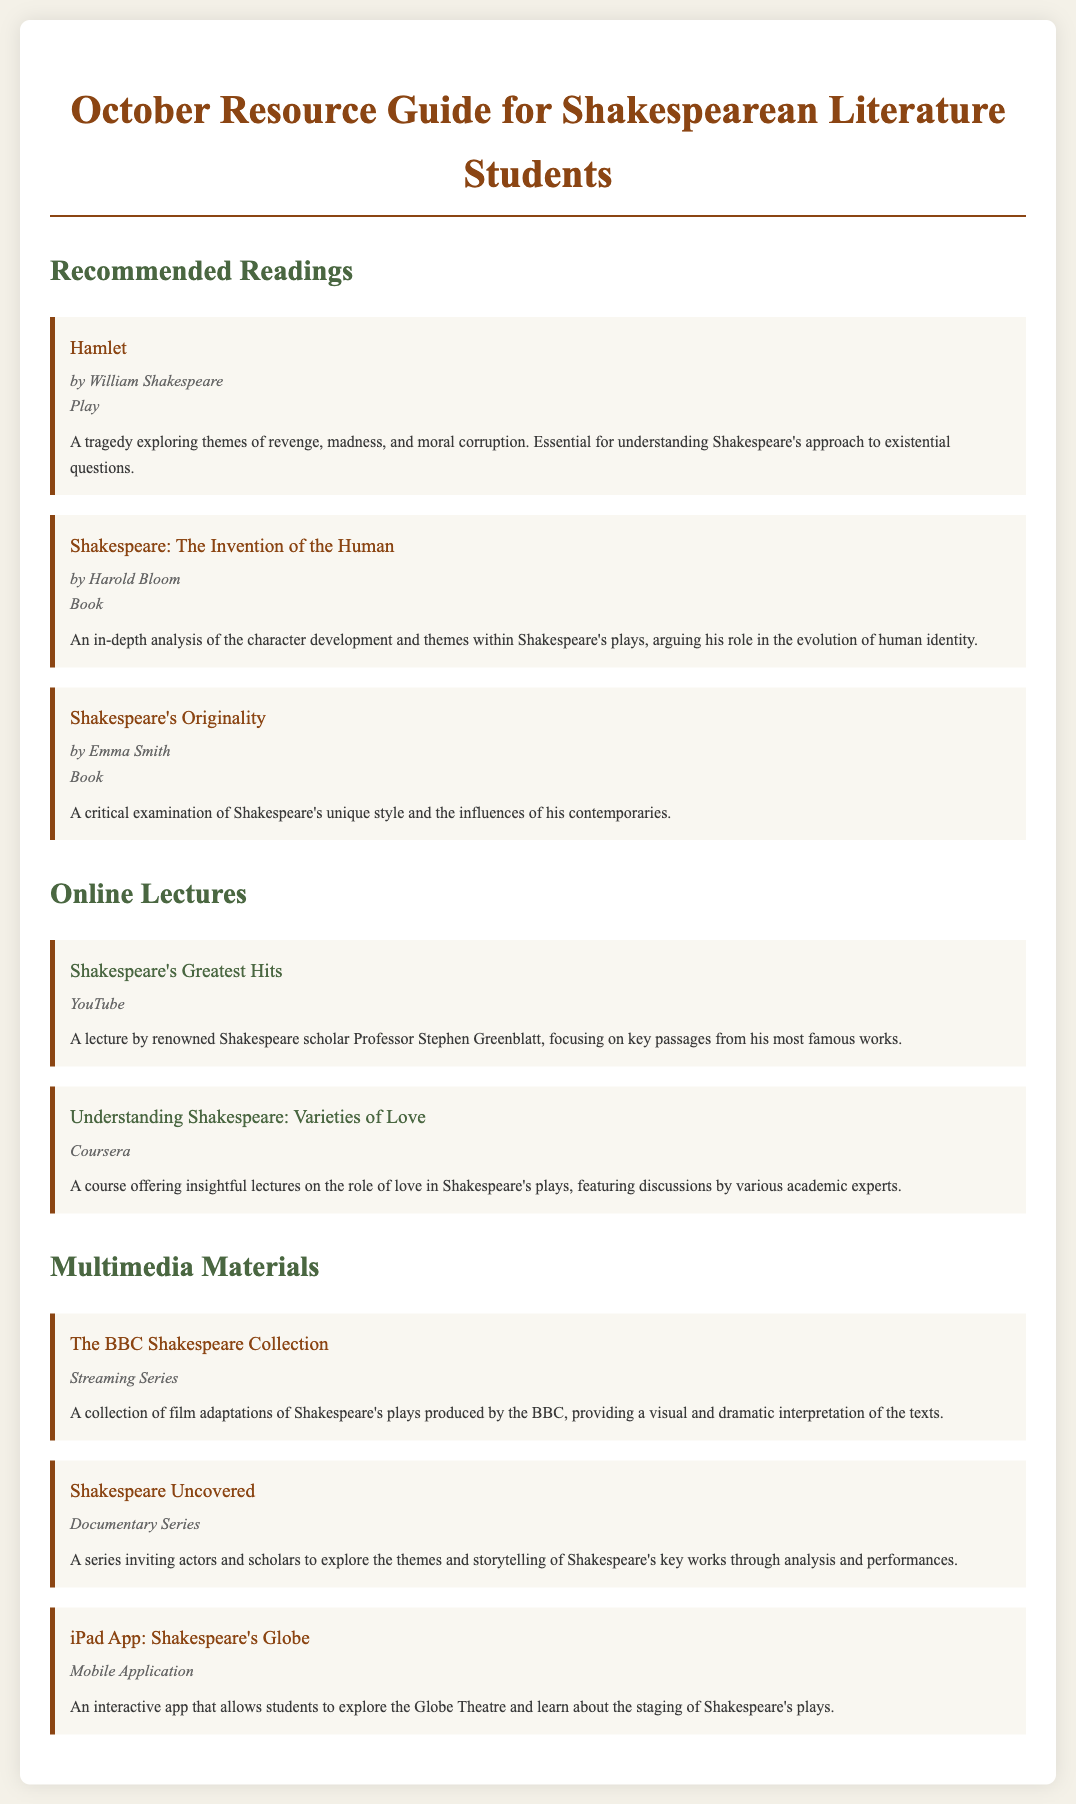What is the title of the first recommended reading? The first recommended reading listed in the document is "Hamlet".
Answer: Hamlet Who is the author of "Shakespeare: The Invention of the Human"? The document states that "Shakespeare: The Invention of the Human" is authored by Harold Bloom.
Answer: Harold Bloom What is the format of "The BBC Shakespeare Collection"? The document defines the format of "The BBC Shakespeare Collection" as a streaming series.
Answer: Streaming Series How many online lectures are listed in the document? There are two online lectures mentioned in the document under the Online Lectures section.
Answer: 2 What theme does the course "Understanding Shakespeare: Varieties of Love" focus on? The theme that "Understanding Shakespeare: Varieties of Love" focuses on is the role of love in Shakespeare's plays.
Answer: Role of love What type of multimedia material is the "Shakespeare's Globe" app? The "Shakespeare's Globe" app is classified as a mobile application.
Answer: Mobile Application Who delivers the lecture titled "Shakespeare's Greatest Hits"? The lecturer for "Shakespeare's Greatest Hits" is Professor Stephen Greenblatt as mentioned in the document.
Answer: Professor Stephen Greenblatt What is the primary focus of "Shakespeare's Originality"? "Shakespeare's Originality" primarily focuses on a critical examination of Shakespeare's unique style.
Answer: Critical examination of Shakespeare's unique style 